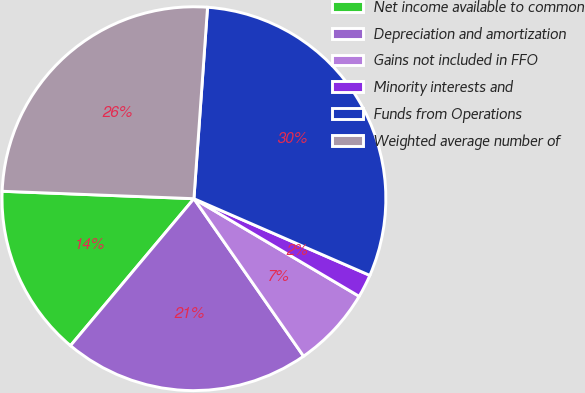<chart> <loc_0><loc_0><loc_500><loc_500><pie_chart><fcel>Net income available to common<fcel>Depreciation and amortization<fcel>Gains not included in FFO<fcel>Minority interests and<fcel>Funds from Operations<fcel>Weighted average number of<nl><fcel>14.5%<fcel>20.8%<fcel>6.83%<fcel>1.95%<fcel>30.42%<fcel>25.52%<nl></chart> 